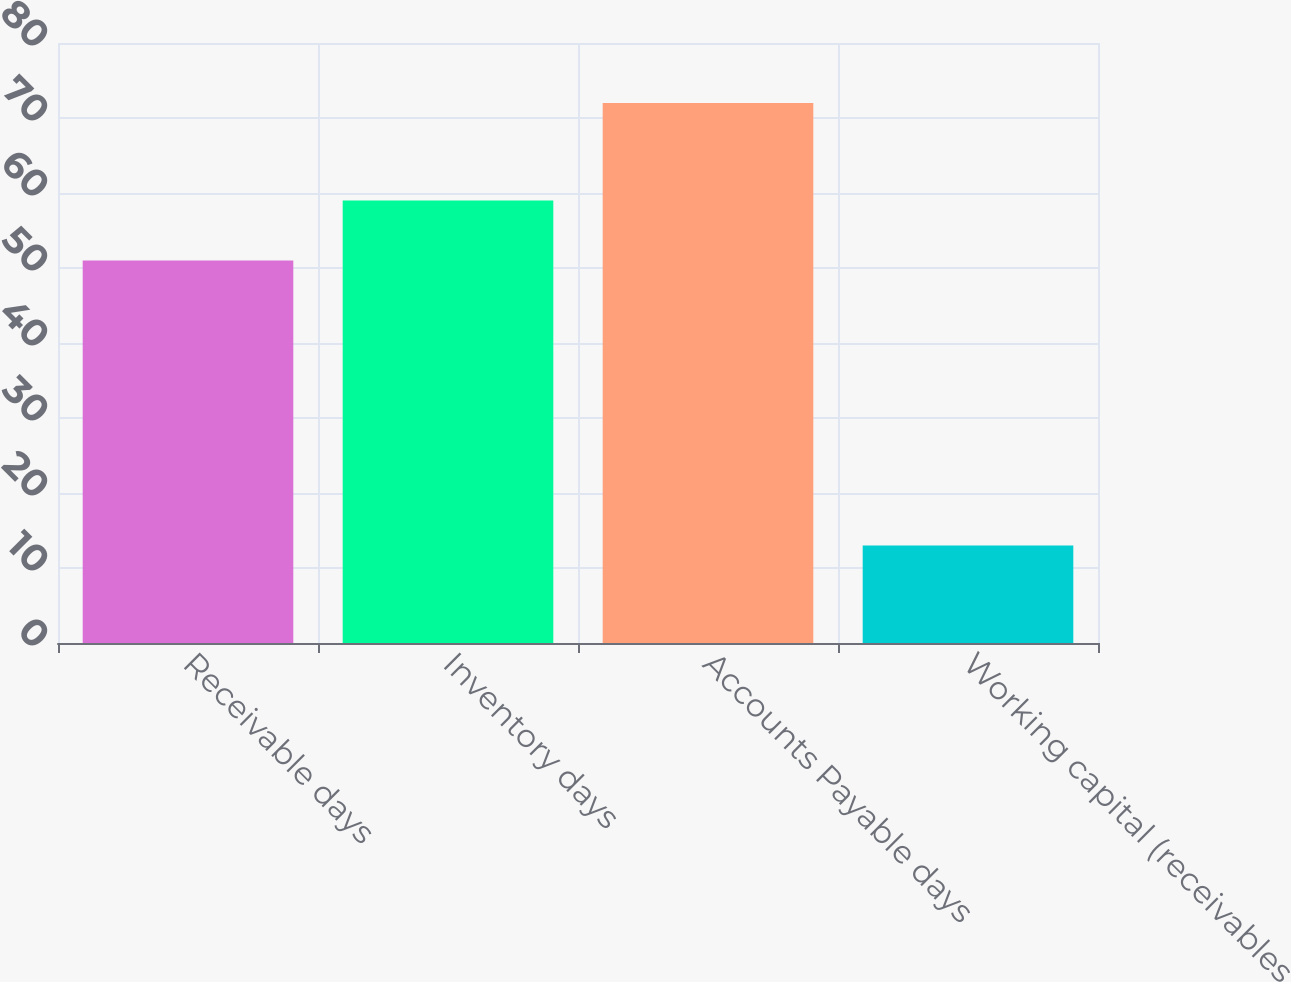<chart> <loc_0><loc_0><loc_500><loc_500><bar_chart><fcel>Receivable days<fcel>Inventory days<fcel>Accounts Payable days<fcel>Working capital (receivables<nl><fcel>51<fcel>59<fcel>72<fcel>13<nl></chart> 